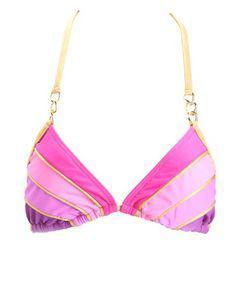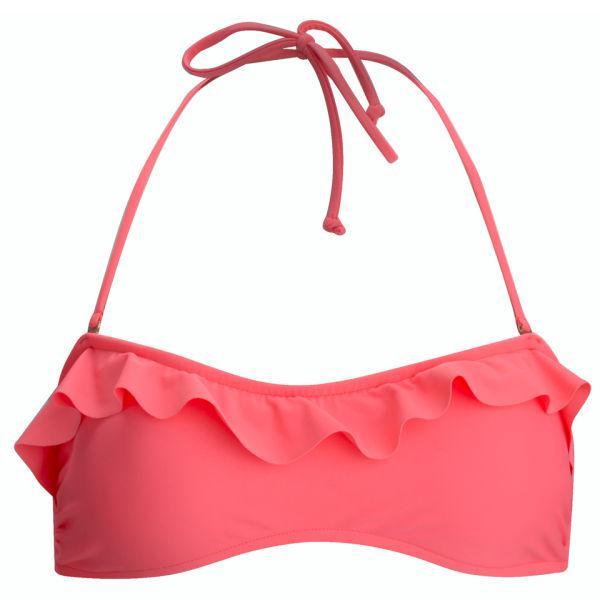The first image is the image on the left, the second image is the image on the right. For the images shown, is this caption "Only the right image shows a bikini top and bottom." true? Answer yes or no. No. 